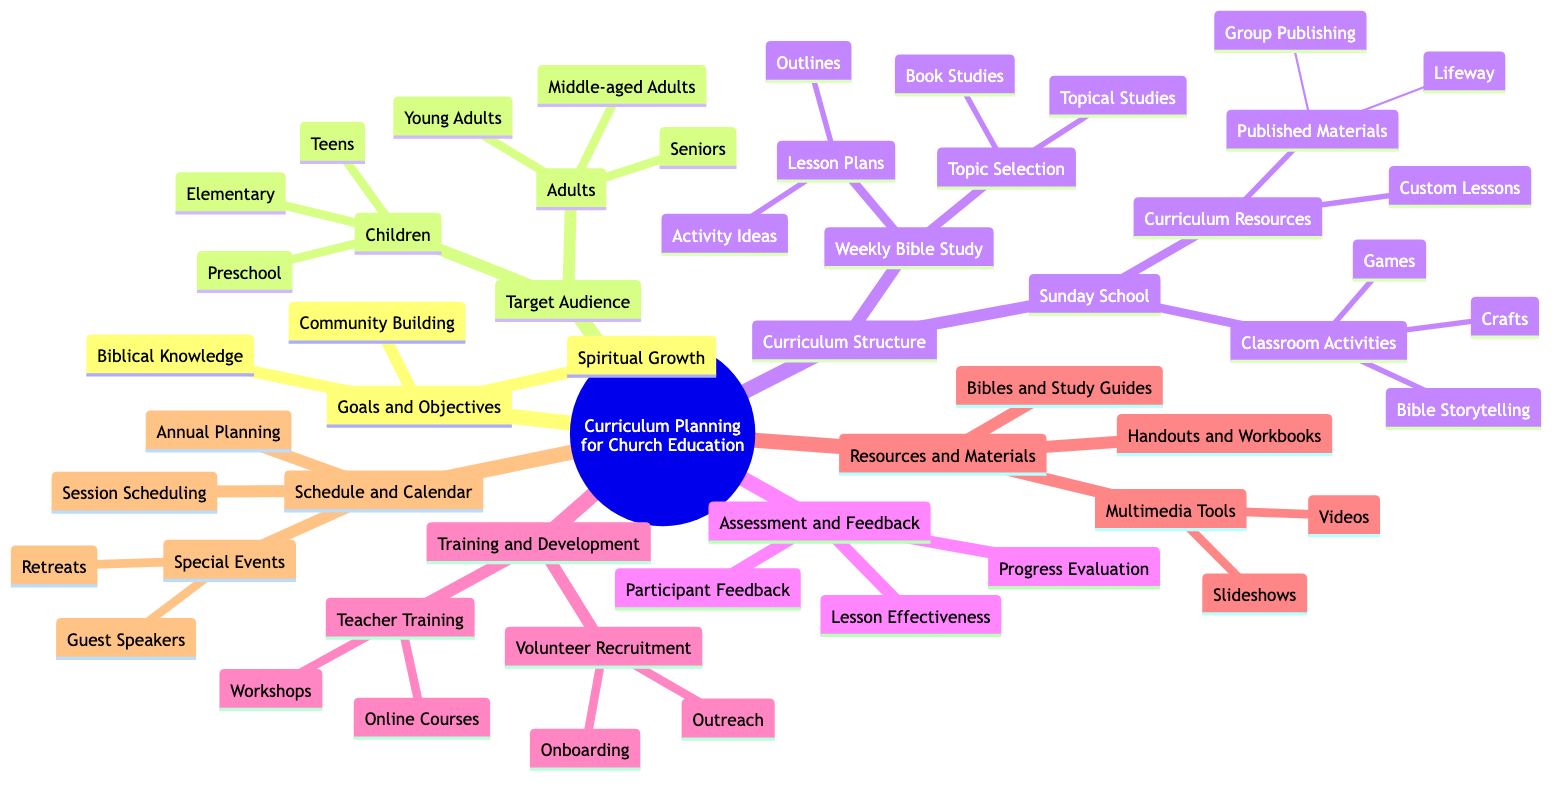What are the three goals listed in the curriculum planning? The diagram lists Spiritual Growth, Biblical Knowledge, and Community Building as the three goals under the Goals and Objectives node.
Answer: Spiritual Growth, Biblical Knowledge, Community Building How many target audience categories are there? There are two main categories listed under Target Audience: Adults and Children. This totals to two categories.
Answer: 2 What structure is used for Weekly Bible Study? Under Curriculum Structure, Weekly Bible Study consists of Topic Selection and Lesson Plans as its components.
Answer: Topic Selection and Lesson Plans Which age group falls under the Adults category? The diagram specifies Young Adults, Middle-aged Adults, and Seniors as the age groups that fall under the Adults category.
Answer: Young Adults, Middle-aged Adults, Seniors What types of resources are mentioned for Sunday School? The resources mentioned for Sunday School include Published Materials, which contains Lifeway and Group Publishing, and Custom Lessons.
Answer: Published Materials, Custom Lessons Which training component includes Online Courses? Under Training and Development, the Teacher Training node explicitly includes Online Courses as one component of teacher training.
Answer: Online Courses What are two activities listed under Classroom Activities? The diagram lists Bible Storytelling and Crafts as two of the activities under Classroom Activities in the Sunday School section.
Answer: Bible Storytelling, Crafts What is one purpose of Assessment and Feedback? Assessment and Feedback include evaluating the effectiveness of lessons as one of its purposes to ensure the curriculum meets educational goals.
Answer: Lesson Effectiveness Which multimedia tools are referenced in the Resources and Materials section? The Resources and Materials section references Videos and Slideshows as the multimedia tools available.
Answer: Videos, Slideshows 